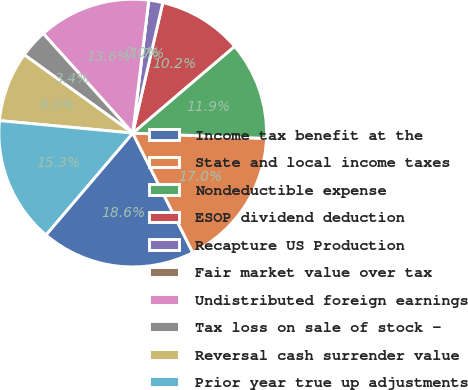<chart> <loc_0><loc_0><loc_500><loc_500><pie_chart><fcel>Income tax benefit at the<fcel>State and local income taxes<fcel>Nondeductible expense<fcel>ESOP dividend deduction<fcel>Recapture US Production<fcel>Fair market value over tax<fcel>Undistributed foreign earnings<fcel>Tax loss on sale of stock -<fcel>Reversal cash surrender value<fcel>Prior year true up adjustments<nl><fcel>18.64%<fcel>16.95%<fcel>11.86%<fcel>10.17%<fcel>1.7%<fcel>0.0%<fcel>13.56%<fcel>3.39%<fcel>8.47%<fcel>15.25%<nl></chart> 